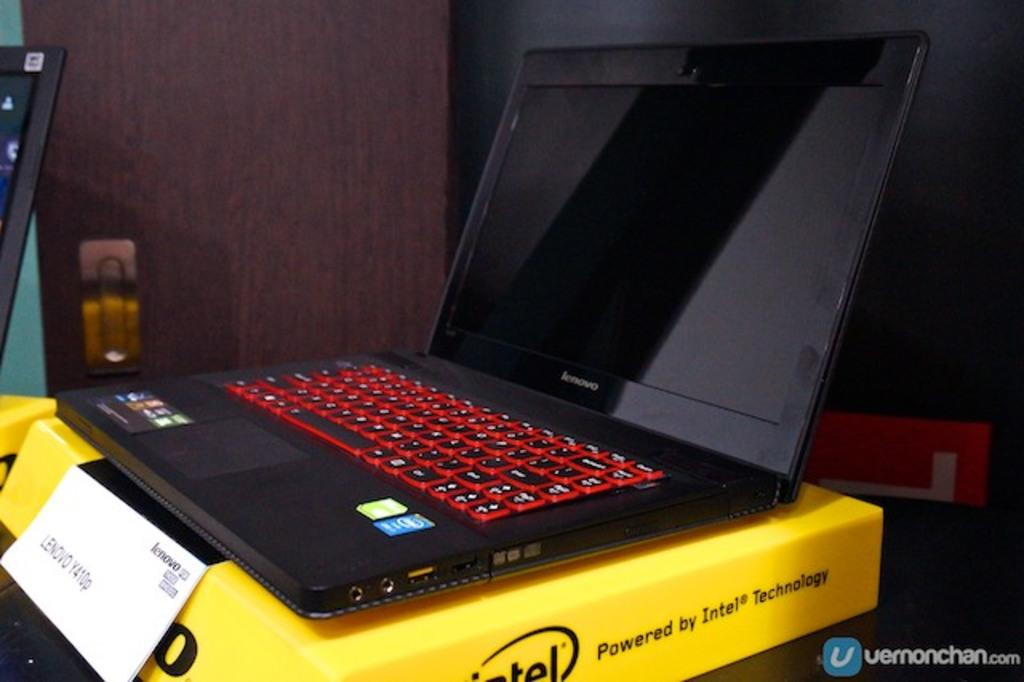<image>
Share a concise interpretation of the image provided. The laptop sits on a yellow intel box 